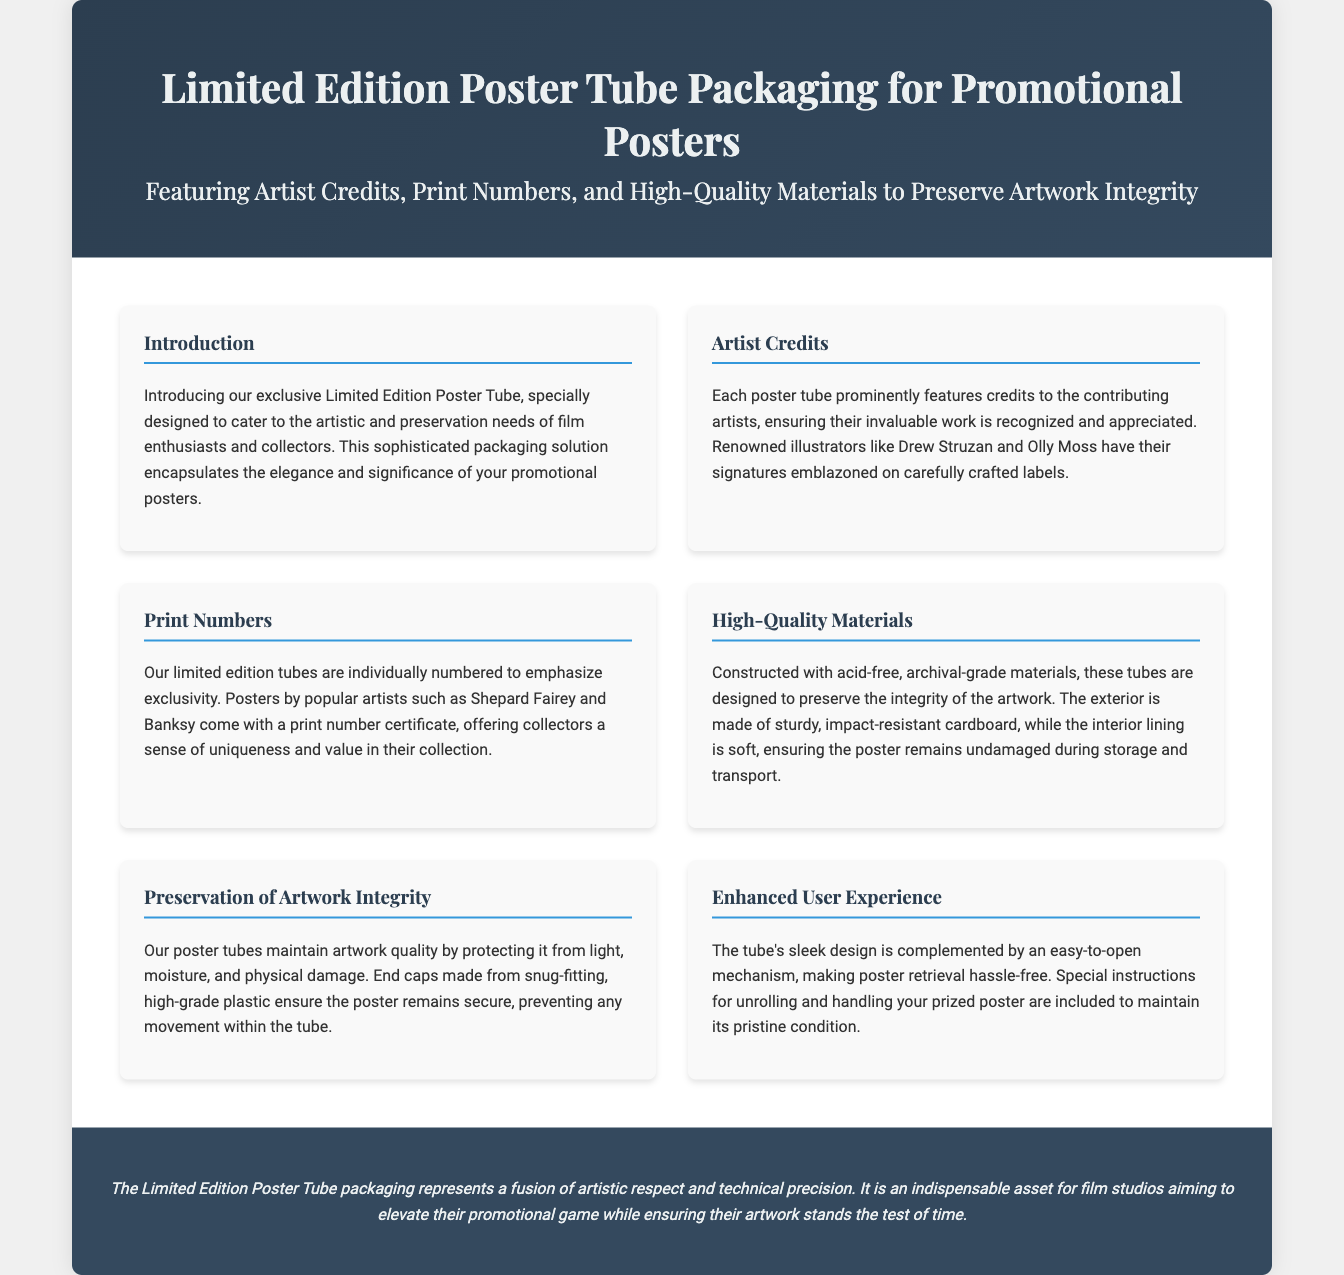What is the title of the document? The title is mentioned in the header section which introduces the product being described.
Answer: Limited Edition Poster Tube Packaging for Promotional Posters Who are some of the artists credited on the poster tubes? The document explicitly names a few renowned illustrators contributing to the packaging.
Answer: Drew Struzan and Olly Moss What material are the poster tubes made of? The document describes the materials used in the construction of the poster tube that relate to its durability and preservation capabilities.
Answer: Acid-free, archival-grade materials What does each limited edition tube come with? The document mentions a specific feature that emphasizes the exclusivity of each tube.
Answer: Print number certificate What is the primary function of the end caps? The document explains the purpose of the end caps in relation to the security of the posters inside the tubes.
Answer: Prevent movement What additional information is provided for handling the posters? The document refers to supplementary instructions that enhance the user experience related to the product.
Answer: Special instructions for unrolling and handling What does the packaging represent according to the conclusion? The conclusion specifies the significance of the packaging in relation to artistic efforts and technical quality.
Answer: Fusion of artistic respect and technical precision How are the poster tubes designed to protect the artwork? The document outlines specific protective features that contribute to the preservation of the posters inside the tubes.
Answer: Protecting from light, moisture, and physical damage 